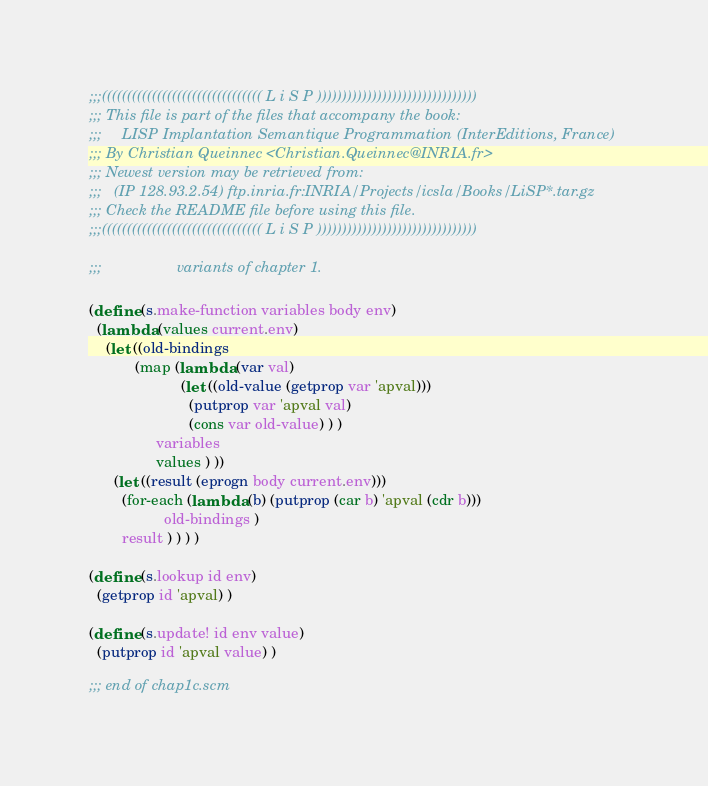Convert code to text. <code><loc_0><loc_0><loc_500><loc_500><_Scheme_>
;;;(((((((((((((((((((((((((((((((( L i S P ))))))))))))))))))))))))))))))))
;;; This file is part of the files that accompany the book:
;;;     LISP Implantation Semantique Programmation (InterEditions, France)
;;; By Christian Queinnec <Christian.Queinnec@INRIA.fr>
;;; Newest version may be retrieved from:
;;;   (IP 128.93.2.54) ftp.inria.fr:INRIA/Projects/icsla/Books/LiSP*.tar.gz
;;; Check the README file before using this file.
;;;(((((((((((((((((((((((((((((((( L i S P ))))))))))))))))))))))))))))))))

;;;                  variants of chapter 1.

(define (s.make-function variables body env)
  (lambda (values current.env)
    (let ((old-bindings
           (map (lambda (var val) 
                      (let ((old-value (getprop var 'apval)))
                        (putprop var 'apval val)
                        (cons var old-value) ) )
                variables
                values ) ))
      (let ((result (eprogn body current.env)))
        (for-each (lambda (b) (putprop (car b) 'apval (cdr b)))
                  old-bindings )
        result ) ) ) )

(define (s.lookup id env)
  (getprop id 'apval) )

(define (s.update! id env value)
  (putprop id 'apval value) ) 

;;; end of chap1c.scm
</code> 